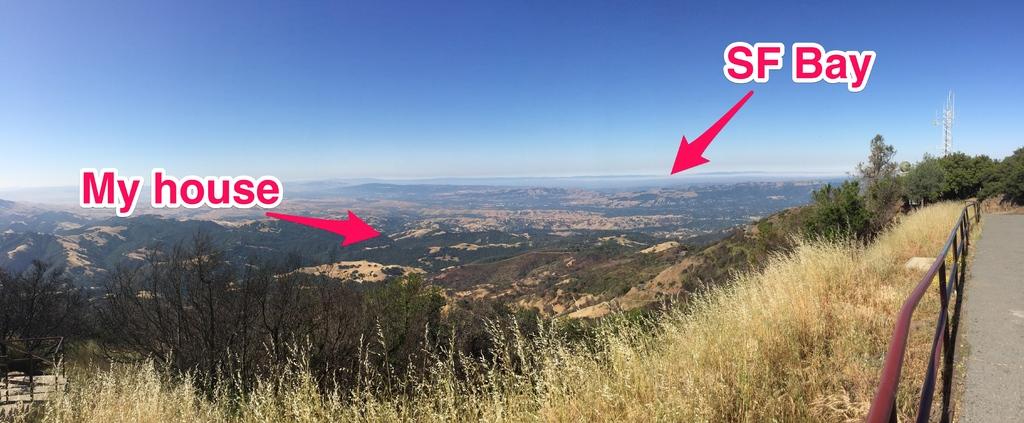This a green valley?
Give a very brief answer. Answering does not require reading text in the image. 